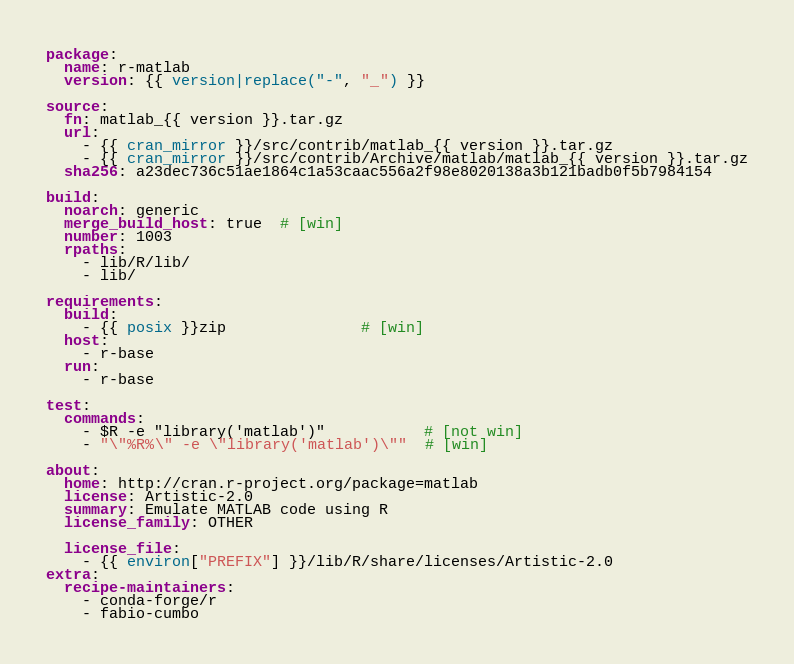<code> <loc_0><loc_0><loc_500><loc_500><_YAML_>package:
  name: r-matlab
  version: {{ version|replace("-", "_") }}

source:
  fn: matlab_{{ version }}.tar.gz
  url:
    - {{ cran_mirror }}/src/contrib/matlab_{{ version }}.tar.gz
    - {{ cran_mirror }}/src/contrib/Archive/matlab/matlab_{{ version }}.tar.gz
  sha256: a23dec736c51ae1864c1a53caac556a2f98e8020138a3b121badb0f5b7984154

build:
  noarch: generic
  merge_build_host: true  # [win]
  number: 1003
  rpaths:
    - lib/R/lib/
    - lib/

requirements:
  build:
    - {{ posix }}zip               # [win]
  host:
    - r-base
  run:
    - r-base

test:
  commands:
    - $R -e "library('matlab')"           # [not win]
    - "\"%R%\" -e \"library('matlab')\""  # [win]

about:
  home: http://cran.r-project.org/package=matlab
  license: Artistic-2.0
  summary: Emulate MATLAB code using R
  license_family: OTHER

  license_file:
    - {{ environ["PREFIX"] }}/lib/R/share/licenses/Artistic-2.0
extra:
  recipe-maintainers:
    - conda-forge/r
    - fabio-cumbo
</code> 